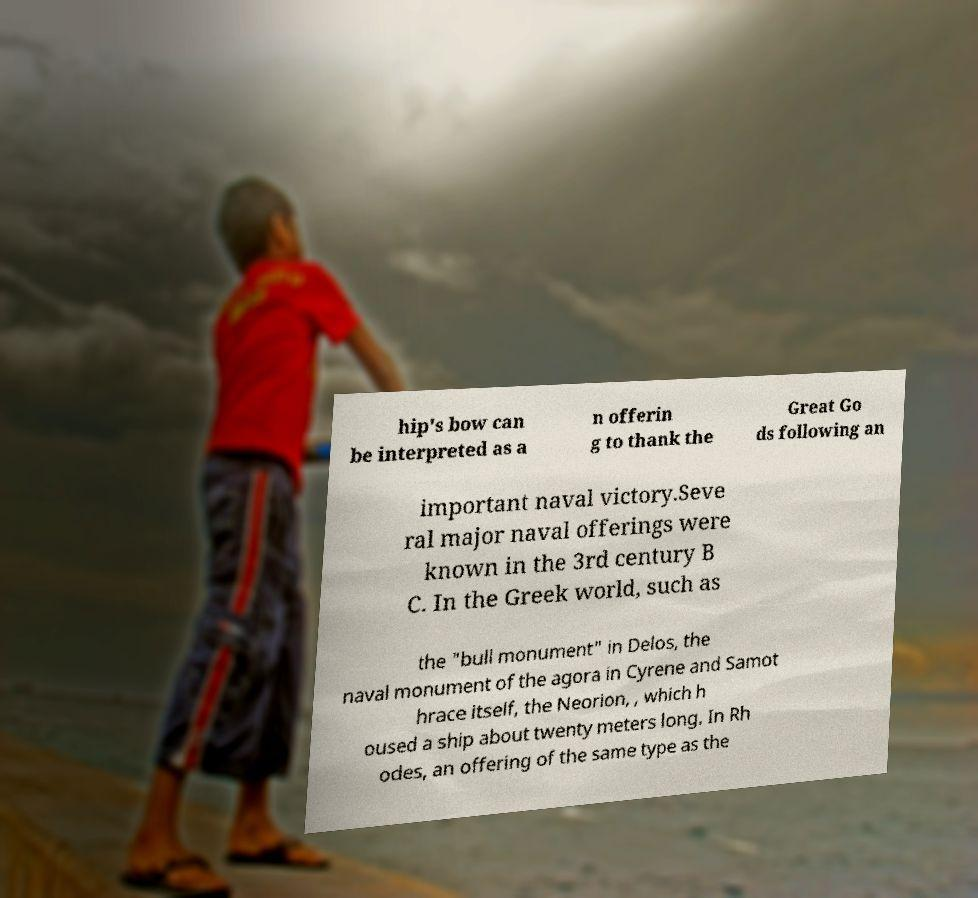Can you read and provide the text displayed in the image?This photo seems to have some interesting text. Can you extract and type it out for me? hip's bow can be interpreted as a n offerin g to thank the Great Go ds following an important naval victory.Seve ral major naval offerings were known in the 3rd century B C. In the Greek world, such as the "bull monument" in Delos, the naval monument of the agora in Cyrene and Samot hrace itself, the Neorion, , which h oused a ship about twenty meters long. In Rh odes, an offering of the same type as the 